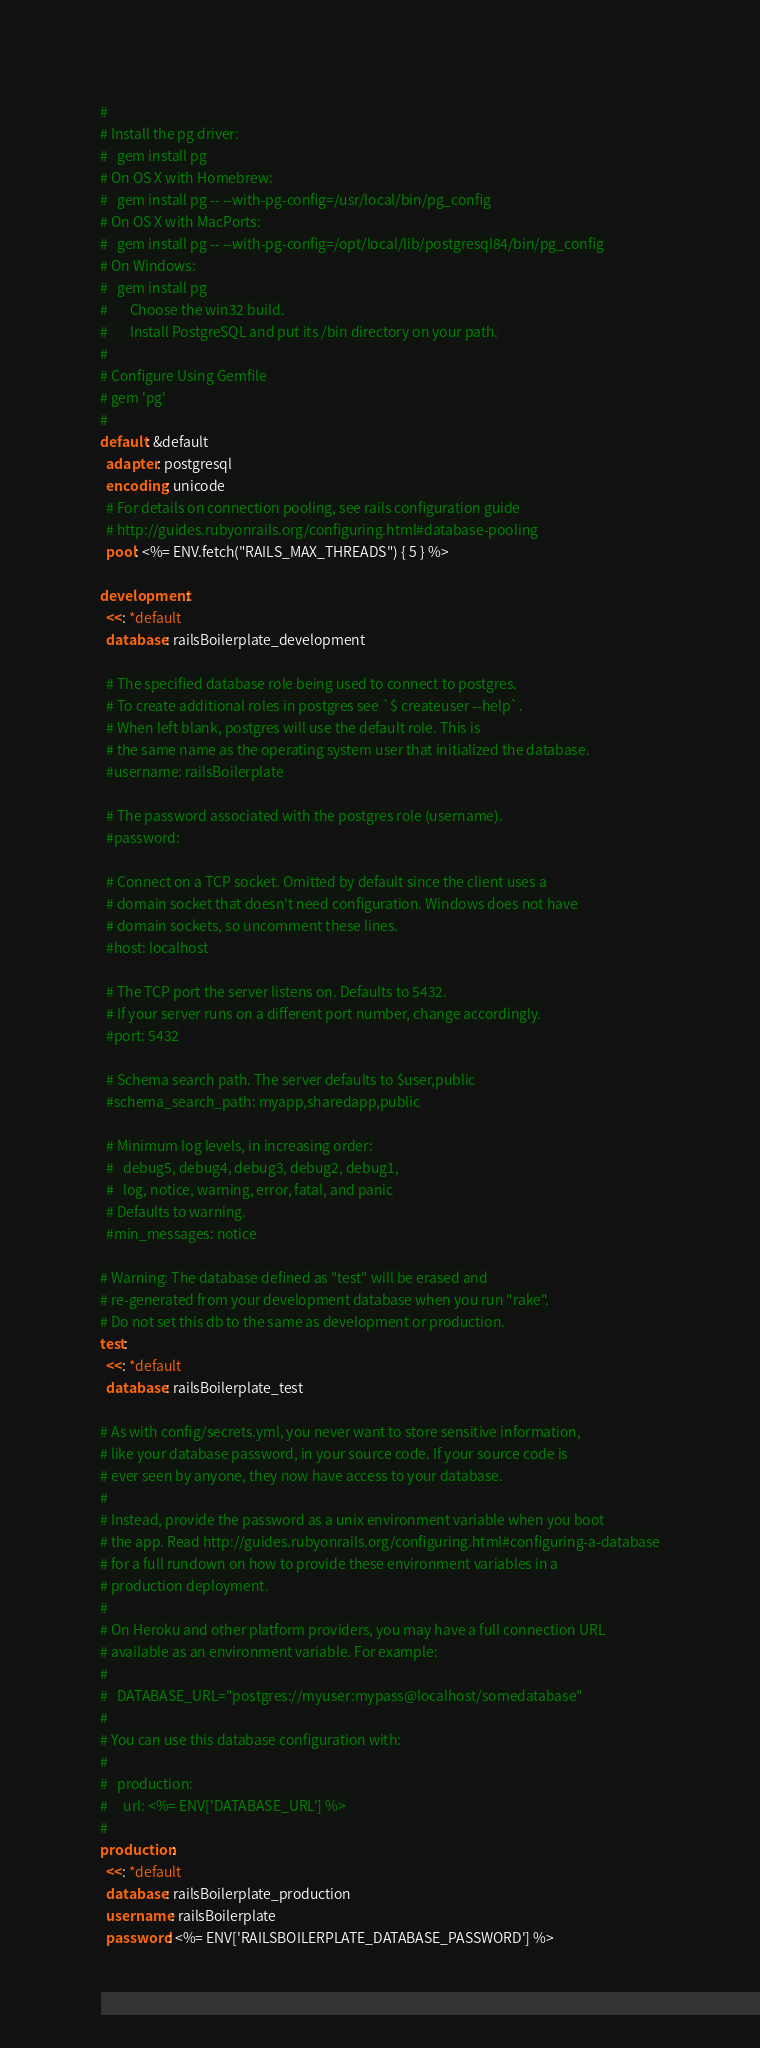Convert code to text. <code><loc_0><loc_0><loc_500><loc_500><_YAML_>#
# Install the pg driver:
#   gem install pg
# On OS X with Homebrew:
#   gem install pg -- --with-pg-config=/usr/local/bin/pg_config
# On OS X with MacPorts:
#   gem install pg -- --with-pg-config=/opt/local/lib/postgresql84/bin/pg_config
# On Windows:
#   gem install pg
#       Choose the win32 build.
#       Install PostgreSQL and put its /bin directory on your path.
#
# Configure Using Gemfile
# gem 'pg'
#
default: &default
  adapter: postgresql
  encoding: unicode
  # For details on connection pooling, see rails configuration guide
  # http://guides.rubyonrails.org/configuring.html#database-pooling
  pool: <%= ENV.fetch("RAILS_MAX_THREADS") { 5 } %>

development:
  <<: *default
  database: railsBoilerplate_development

  # The specified database role being used to connect to postgres.
  # To create additional roles in postgres see `$ createuser --help`.
  # When left blank, postgres will use the default role. This is
  # the same name as the operating system user that initialized the database.
  #username: railsBoilerplate

  # The password associated with the postgres role (username).
  #password:

  # Connect on a TCP socket. Omitted by default since the client uses a
  # domain socket that doesn't need configuration. Windows does not have
  # domain sockets, so uncomment these lines.
  #host: localhost

  # The TCP port the server listens on. Defaults to 5432.
  # If your server runs on a different port number, change accordingly.
  #port: 5432

  # Schema search path. The server defaults to $user,public
  #schema_search_path: myapp,sharedapp,public

  # Minimum log levels, in increasing order:
  #   debug5, debug4, debug3, debug2, debug1,
  #   log, notice, warning, error, fatal, and panic
  # Defaults to warning.
  #min_messages: notice

# Warning: The database defined as "test" will be erased and
# re-generated from your development database when you run "rake".
# Do not set this db to the same as development or production.
test:
  <<: *default
  database: railsBoilerplate_test

# As with config/secrets.yml, you never want to store sensitive information,
# like your database password, in your source code. If your source code is
# ever seen by anyone, they now have access to your database.
#
# Instead, provide the password as a unix environment variable when you boot
# the app. Read http://guides.rubyonrails.org/configuring.html#configuring-a-database
# for a full rundown on how to provide these environment variables in a
# production deployment.
#
# On Heroku and other platform providers, you may have a full connection URL
# available as an environment variable. For example:
#
#   DATABASE_URL="postgres://myuser:mypass@localhost/somedatabase"
#
# You can use this database configuration with:
#
#   production:
#     url: <%= ENV['DATABASE_URL'] %>
#
production:
  <<: *default
  database: railsBoilerplate_production
  username: railsBoilerplate
  password: <%= ENV['RAILSBOILERPLATE_DATABASE_PASSWORD'] %>
</code> 